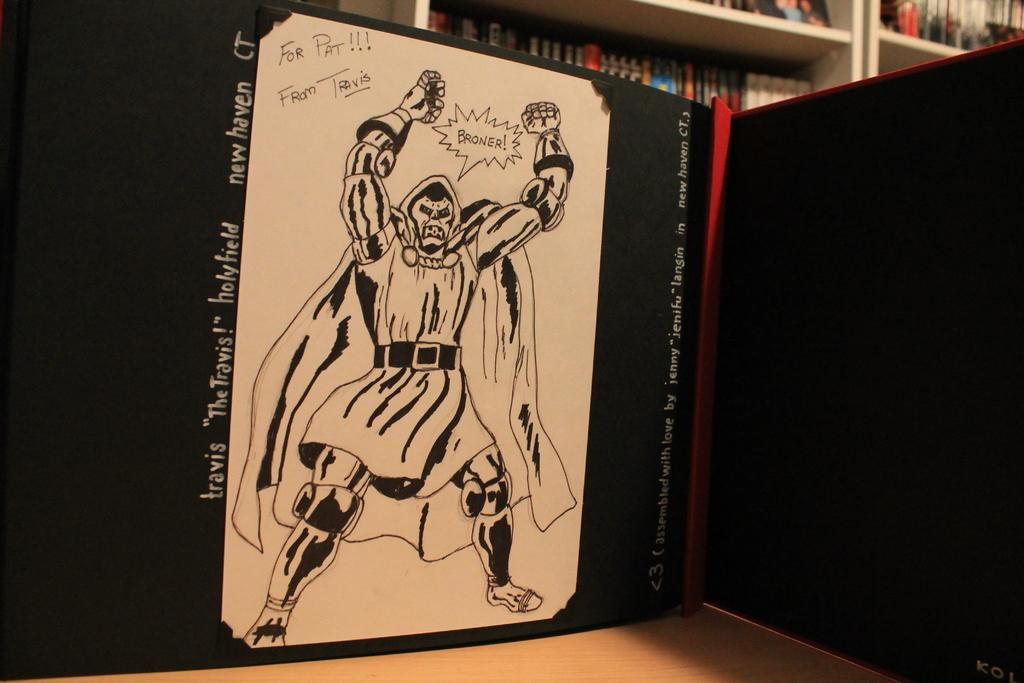<image>
Relay a brief, clear account of the picture shown. A drawing of Travis the holy field broner picture. 